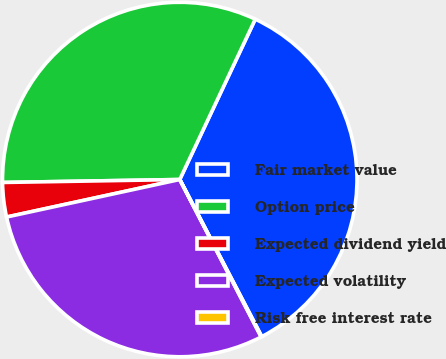<chart> <loc_0><loc_0><loc_500><loc_500><pie_chart><fcel>Fair market value<fcel>Option price<fcel>Expected dividend yield<fcel>Expected volatility<fcel>Risk free interest rate<nl><fcel>35.34%<fcel>32.27%<fcel>3.13%<fcel>29.2%<fcel>0.06%<nl></chart> 